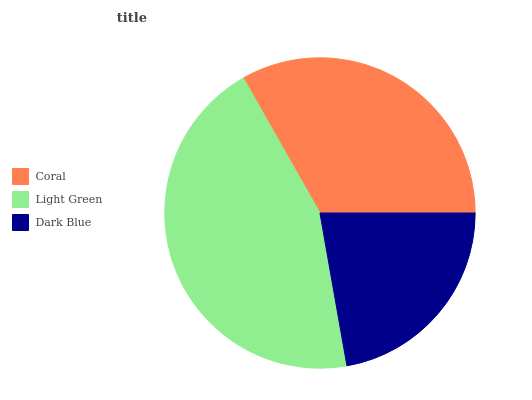Is Dark Blue the minimum?
Answer yes or no. Yes. Is Light Green the maximum?
Answer yes or no. Yes. Is Light Green the minimum?
Answer yes or no. No. Is Dark Blue the maximum?
Answer yes or no. No. Is Light Green greater than Dark Blue?
Answer yes or no. Yes. Is Dark Blue less than Light Green?
Answer yes or no. Yes. Is Dark Blue greater than Light Green?
Answer yes or no. No. Is Light Green less than Dark Blue?
Answer yes or no. No. Is Coral the high median?
Answer yes or no. Yes. Is Coral the low median?
Answer yes or no. Yes. Is Dark Blue the high median?
Answer yes or no. No. Is Light Green the low median?
Answer yes or no. No. 